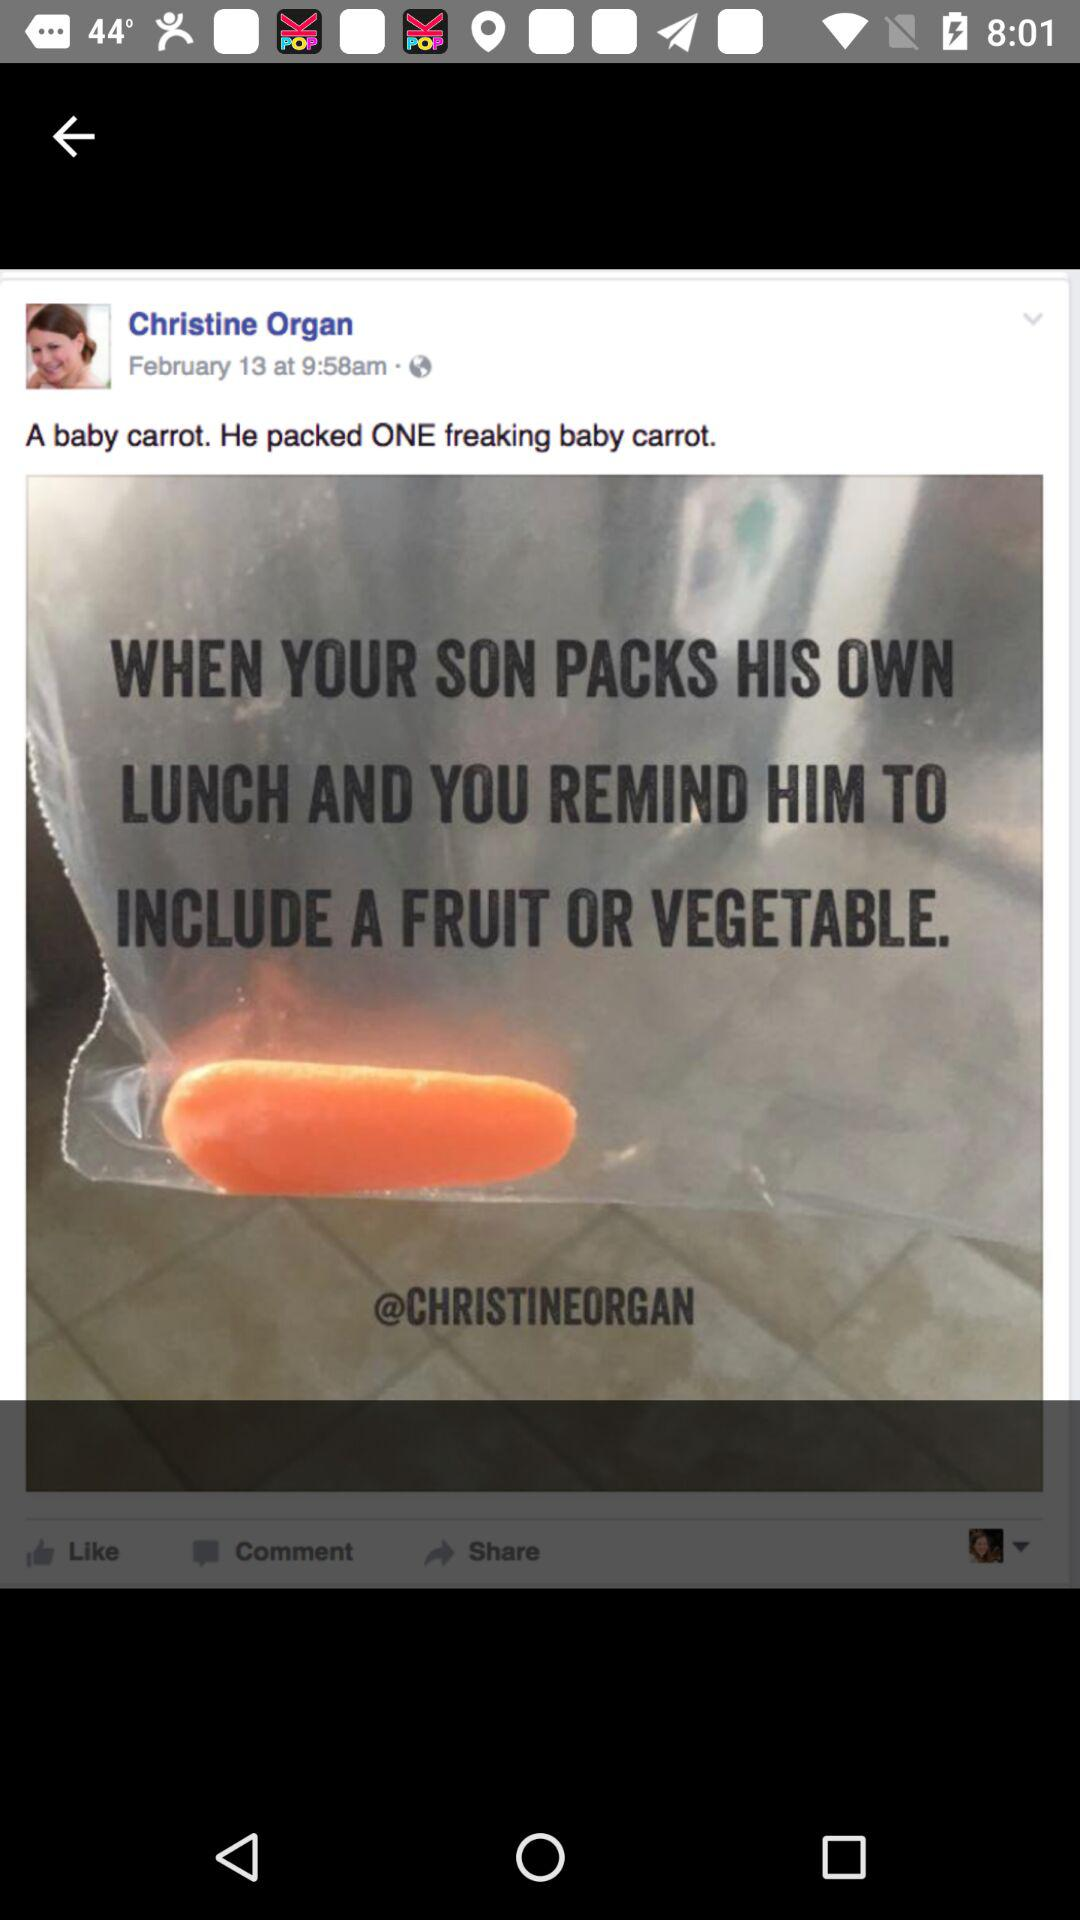What is the user name? The user name is Christine Organ. 